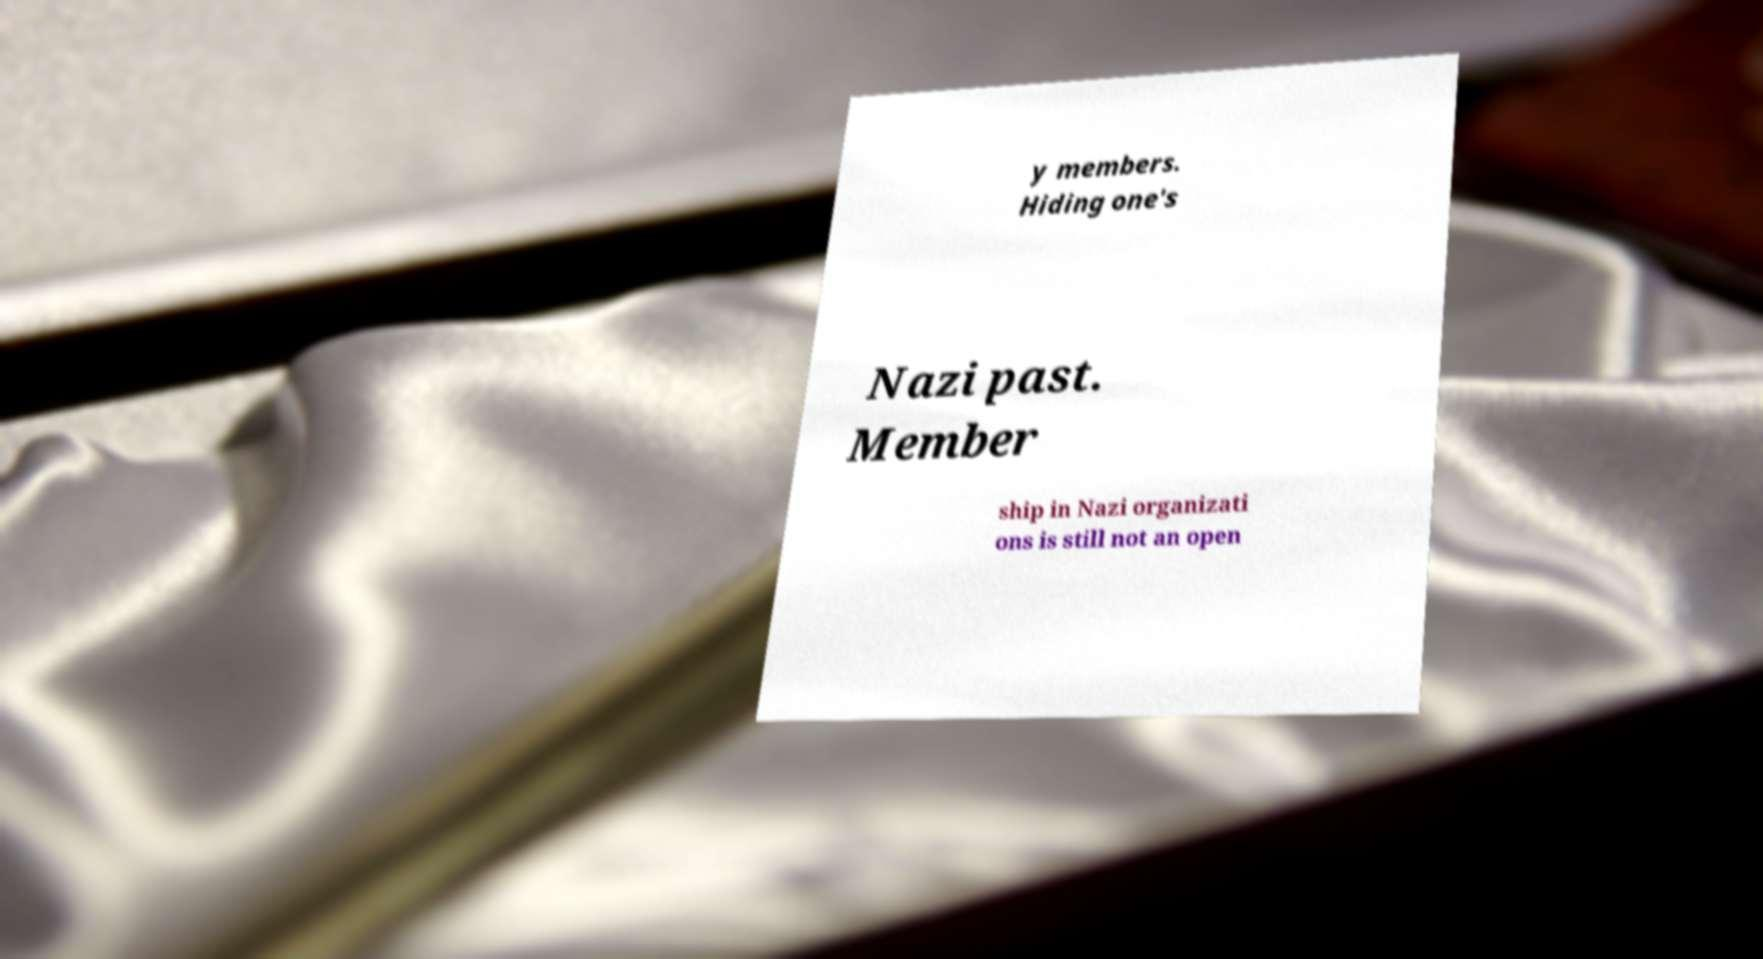Could you extract and type out the text from this image? y members. Hiding one's Nazi past. Member ship in Nazi organizati ons is still not an open 